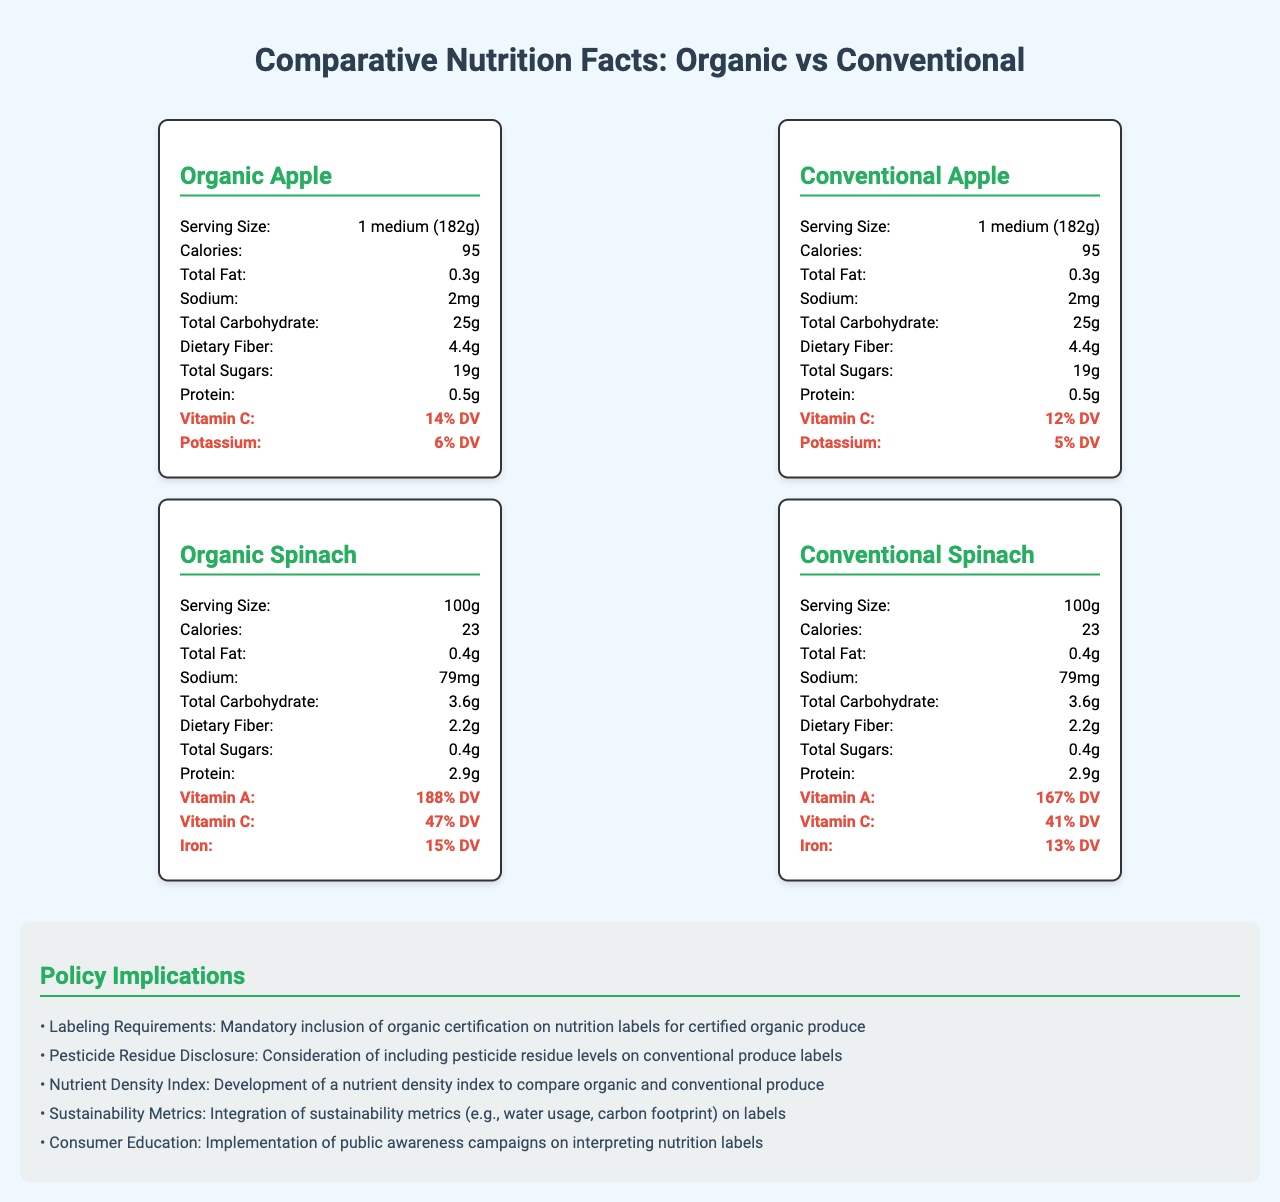what is the serving size for an organic apple? The label for the organic apple shows a serving size of 1 medium (182g).
Answer: 1 medium (182g) how many calories are in a serving of conventional spinach? The label for the conventional spinach specifies that it has 23 calories per 100g serving.
Answer: 23 calories what percentage of the daily value of Vitamin C is found in a serving of organic apple? The organic apple's nutrition label indicates it provides 14% of the daily value (DV) for Vitamin C.
Answer: 14% DV which type of apple, organic or conventional, has more vitamin C? The organic apple has 14% DV of Vitamin C, whereas the conventional apple has 12% DV of Vitamin C.
Answer: Organic apple how much protein does 100g of organic spinach contain? The label for organic spinach shows it contains 2.9g of protein per 100g serving.
Answer: 2.9g which of the following contains more iron? A. Organic Spinach B. Conventional Spinach C. Organic Apple D. Conventional Apple Organic spinach contains 15% DV of iron, which is higher compared to the other options listed.
Answer: A. Organic Spinach what is the difference in Vitamin A content between organic and conventional spinach? A. 21% DV B. 5% DV C. 15% DV D. 10% DV Organic spinach has 188% DV of Vitamin A while conventional spinach has 167% DV, so the difference is 21% DV.
Answer: A. 21% DV does the conventional apple have more dietary fiber than the organic apple? Both the conventional and organic apples contain 4.4g of dietary fiber as specified on their labels.
Answer: No summarize the main insights provided by the document The document compares nutritional content of organic vs. conventional produce, detailing differences and suggesting policy implications including labeling and consumer education.
Answer: The document provides a comparative analysis of nutrition facts between organic and conventional produce, specifically apples and spinach. It highlights differences in nutrients like Vitamin C, Vitamin A, and iron. Additionally, it mentions policy implications such as labeling requirements and consumer education initiatives. what are the policy implications mentioned regarding sustainability? The document mentions integrating sustainability metrics such as water usage and carbon footprint on labels as a policy implication.
Answer: Sustainability metrics integration on labels how much sodium is in a serving of conventional apple? The label for conventional apple lists 2mg of sodium per serving.
Answer: 2mg what is the total carbohydrate content in a serving of organic apple? The organic apple's nutrition label shows it contains 25g of total carbohydrates per serving.
Answer: 25g are the total sugars in conventional spinach higher than those in organic spinach? Both conventional and organic spinach contain 0.4g of total sugars per 100g serving.
Answer: No is there a significant difference in calories between organic and conventional apples? Both organic and conventional apples have the same calorie count of 95.
Answer: No how does the percentage of potassium in organic and conventional apples compare? The document labels show that organic apples have slightly higher potassium content (6% DV) compared to conventional apples (5% DV).
Answer: Organic apple has 6% DV, while conventional apple has 5% DV which produce type has the better nutrient density index, organic or conventional? The document mentions the development of a nutrient density index as a policy implication but does not provide a value or comparison for it.
Answer: Cannot be determined 